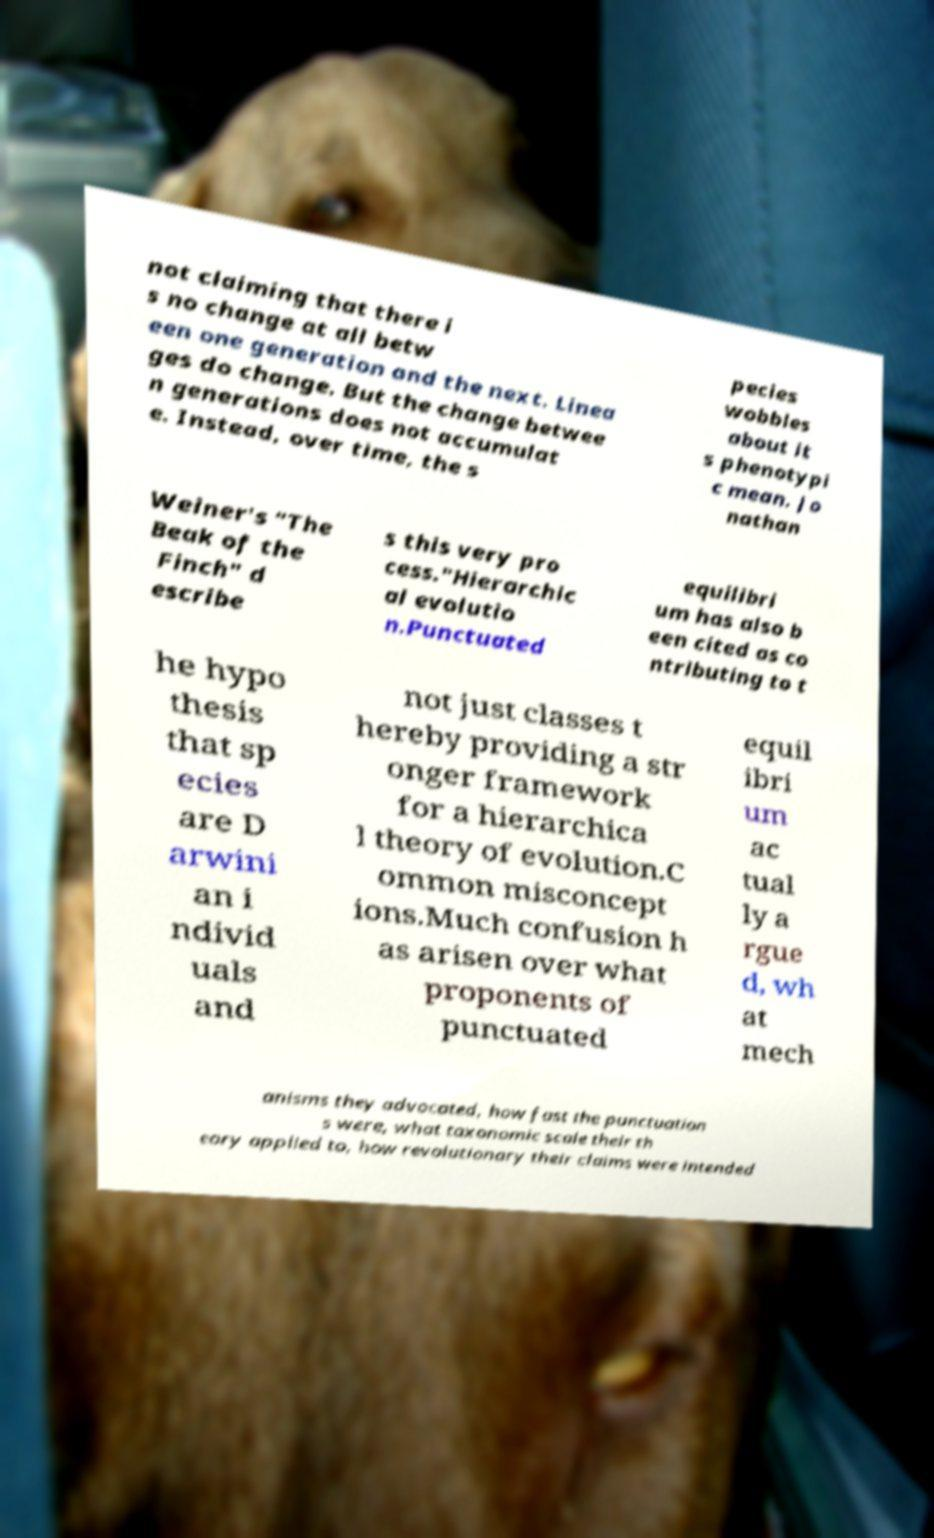For documentation purposes, I need the text within this image transcribed. Could you provide that? not claiming that there i s no change at all betw een one generation and the next. Linea ges do change. But the change betwee n generations does not accumulat e. Instead, over time, the s pecies wobbles about it s phenotypi c mean. Jo nathan Weiner's "The Beak of the Finch" d escribe s this very pro cess."Hierarchic al evolutio n.Punctuated equilibri um has also b een cited as co ntributing to t he hypo thesis that sp ecies are D arwini an i ndivid uals and not just classes t hereby providing a str onger framework for a hierarchica l theory of evolution.C ommon misconcept ions.Much confusion h as arisen over what proponents of punctuated equil ibri um ac tual ly a rgue d, wh at mech anisms they advocated, how fast the punctuation s were, what taxonomic scale their th eory applied to, how revolutionary their claims were intended 